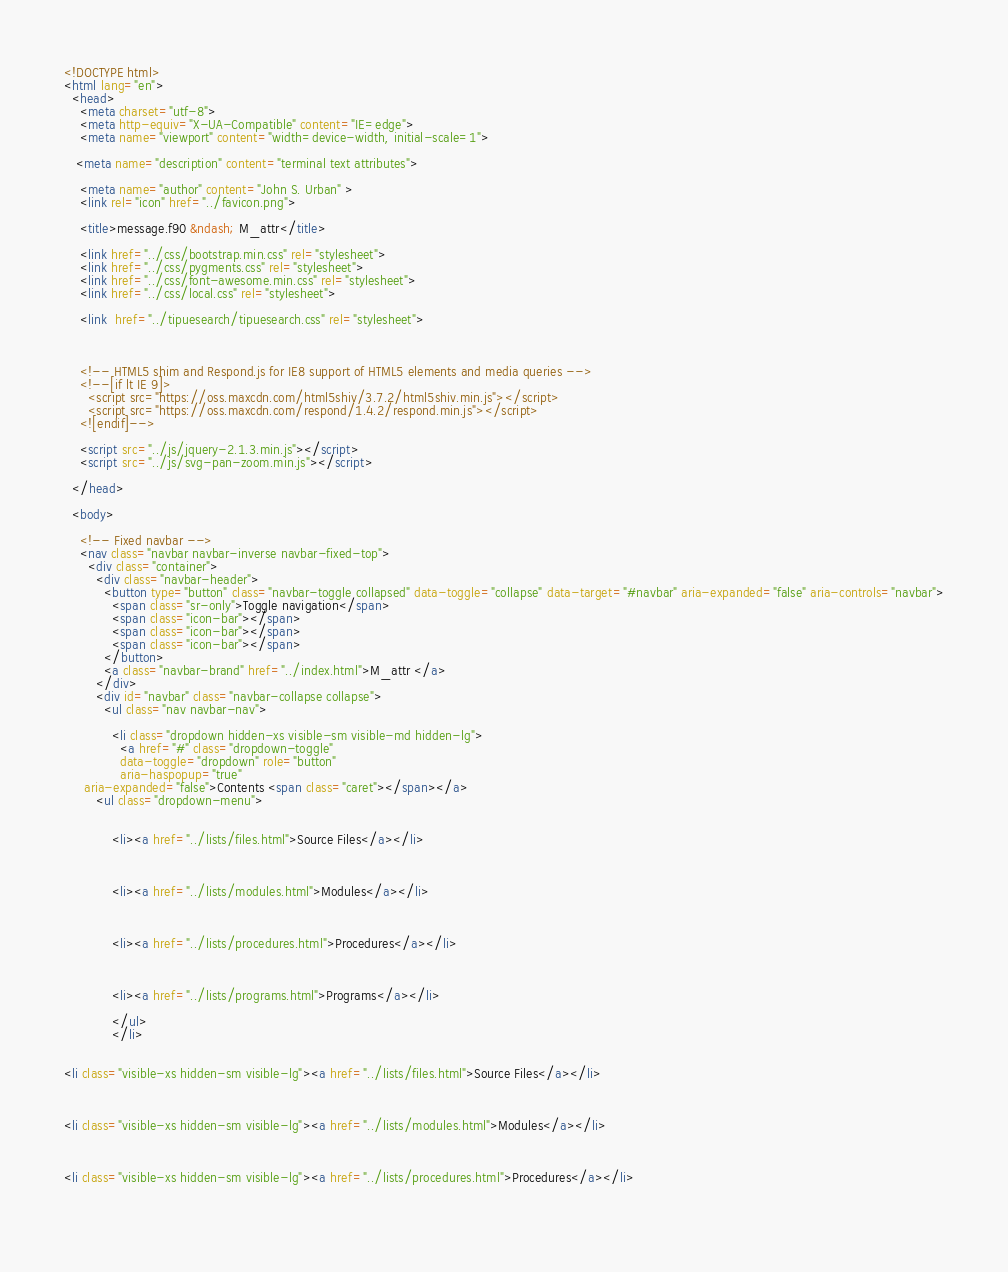Convert code to text. <code><loc_0><loc_0><loc_500><loc_500><_HTML_><!DOCTYPE html>
<html lang="en">
  <head>
    <meta charset="utf-8">
    <meta http-equiv="X-UA-Compatible" content="IE=edge">
    <meta name="viewport" content="width=device-width, initial-scale=1">
   
   <meta name="description" content="terminal text attributes">
    
    <meta name="author" content="John S. Urban" >
    <link rel="icon" href="../favicon.png">

    <title>message.f90 &ndash; M_attr</title>

    <link href="../css/bootstrap.min.css" rel="stylesheet">
    <link href="../css/pygments.css" rel="stylesheet">
    <link href="../css/font-awesome.min.css" rel="stylesheet">
    <link href="../css/local.css" rel="stylesheet">
    
    <link  href="../tipuesearch/tipuesearch.css" rel="stylesheet">
    
    

    <!-- HTML5 shim and Respond.js for IE8 support of HTML5 elements and media queries -->
    <!--[if lt IE 9]>
      <script src="https://oss.maxcdn.com/html5shiv/3.7.2/html5shiv.min.js"></script>
      <script src="https://oss.maxcdn.com/respond/1.4.2/respond.min.js"></script>
    <![endif]-->
    
    <script src="../js/jquery-2.1.3.min.js"></script>
    <script src="../js/svg-pan-zoom.min.js"></script>

  </head>

  <body>

    <!-- Fixed navbar -->
    <nav class="navbar navbar-inverse navbar-fixed-top">
      <div class="container">
        <div class="navbar-header">
          <button type="button" class="navbar-toggle collapsed" data-toggle="collapse" data-target="#navbar" aria-expanded="false" aria-controls="navbar">
            <span class="sr-only">Toggle navigation</span>
            <span class="icon-bar"></span>
            <span class="icon-bar"></span>
            <span class="icon-bar"></span>
          </button>
          <a class="navbar-brand" href="../index.html">M_attr </a>
        </div>
        <div id="navbar" class="navbar-collapse collapse">
          <ul class="nav navbar-nav">
        
            <li class="dropdown hidden-xs visible-sm visible-md hidden-lg">
              <a href="#" class="dropdown-toggle"
              data-toggle="dropdown" role="button"
              aria-haspopup="true"
     aria-expanded="false">Contents <span class="caret"></span></a>
        <ul class="dropdown-menu">
          
              
            <li><a href="../lists/files.html">Source Files</a></li>
        
        
        
            <li><a href="../lists/modules.html">Modules</a></li>
        
            
                                
            <li><a href="../lists/procedures.html">Procedures</a></li>
        
               
        
            <li><a href="../lists/programs.html">Programs</a></li>
        
            </ul>
            </li>


<li class="visible-xs hidden-sm visible-lg"><a href="../lists/files.html">Source Files</a></li>



<li class="visible-xs hidden-sm visible-lg"><a href="../lists/modules.html">Modules</a></li>



<li class="visible-xs hidden-sm visible-lg"><a href="../lists/procedures.html">Procedures</a></li>

                             
</code> 